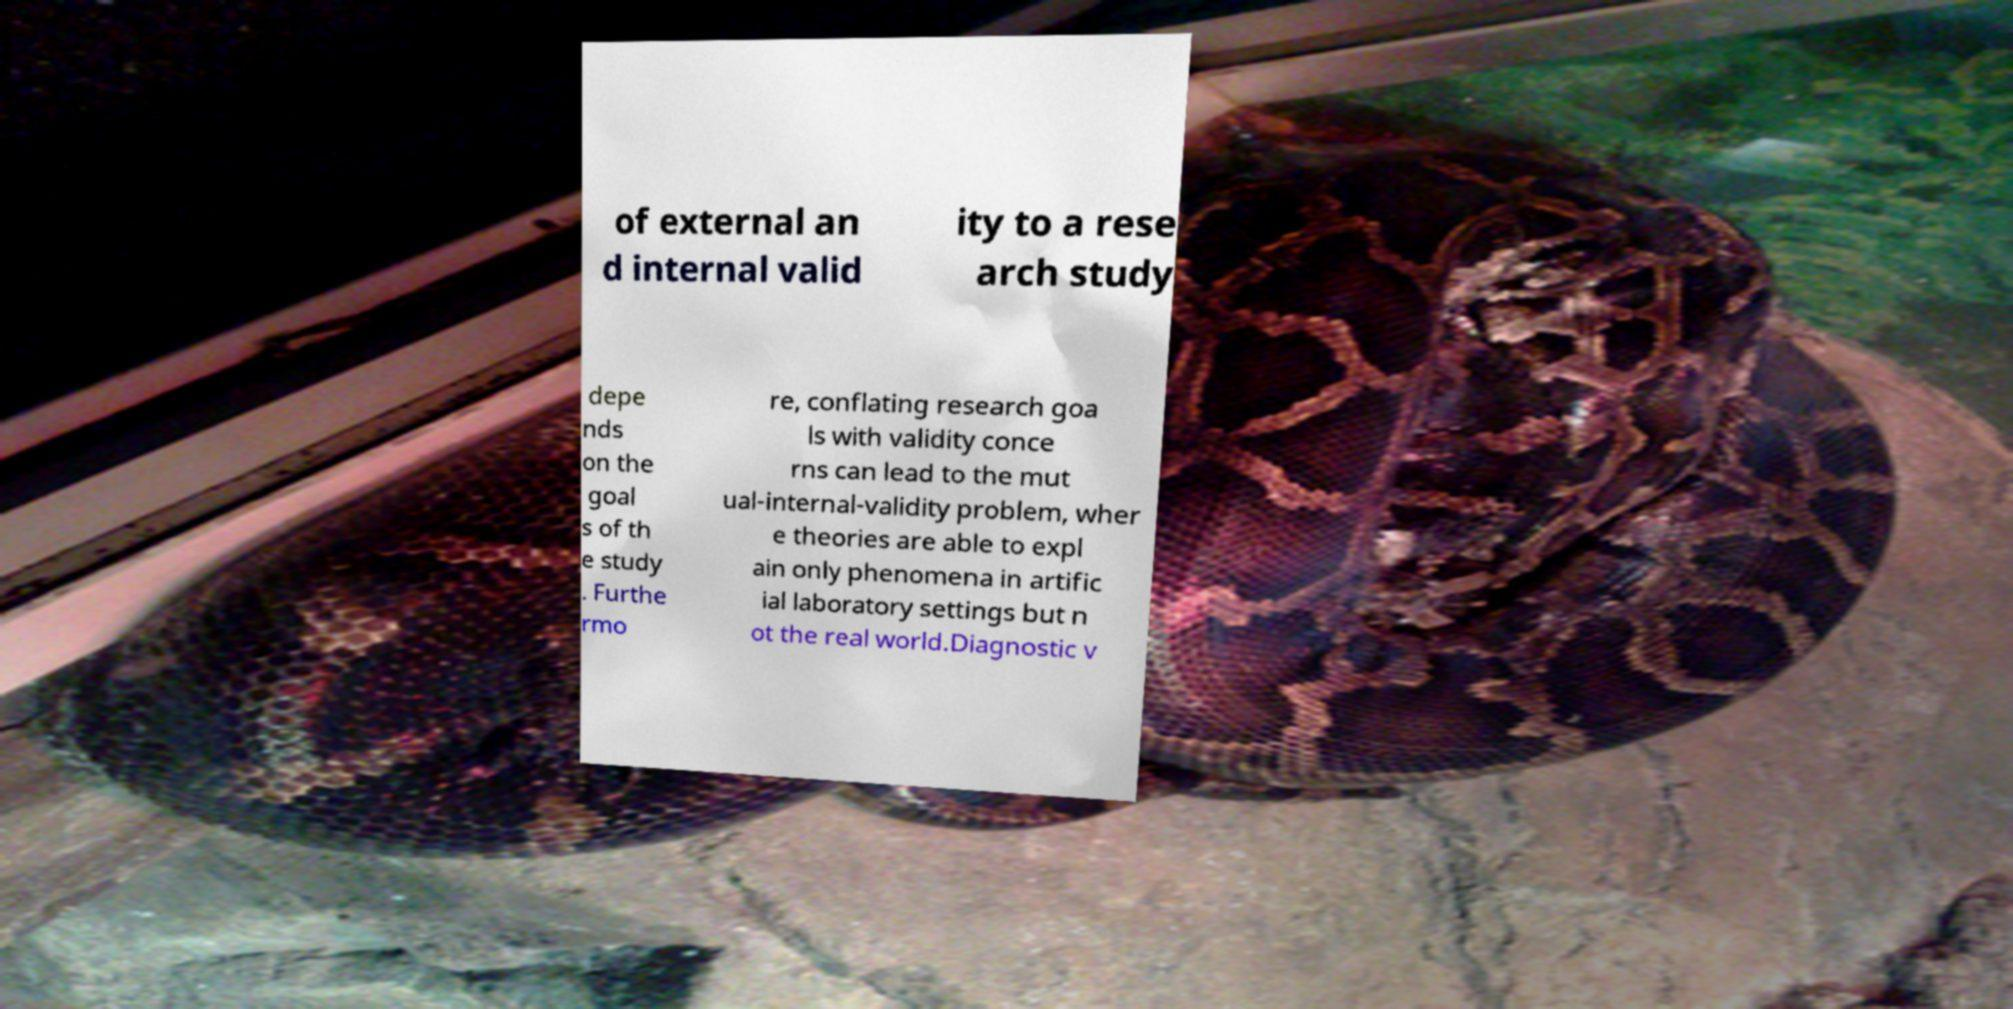Can you read and provide the text displayed in the image?This photo seems to have some interesting text. Can you extract and type it out for me? of external an d internal valid ity to a rese arch study depe nds on the goal s of th e study . Furthe rmo re, conflating research goa ls with validity conce rns can lead to the mut ual-internal-validity problem, wher e theories are able to expl ain only phenomena in artific ial laboratory settings but n ot the real world.Diagnostic v 